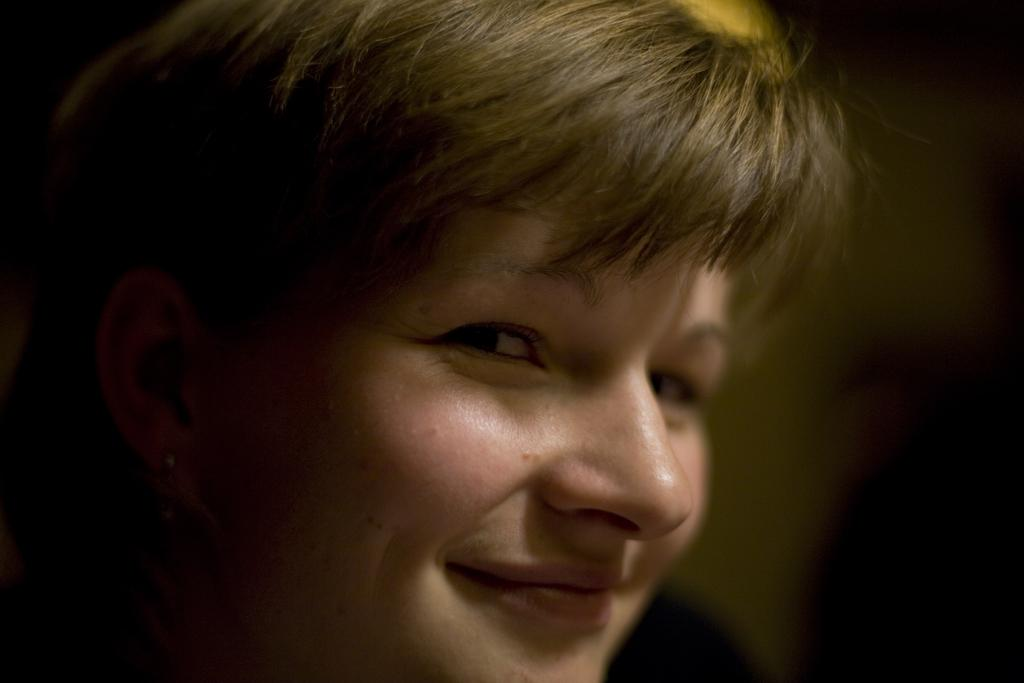What is the focus of the image? The image is zoomed in on a person's head in the foreground. What is the facial expression of the person in the image? The person is smiling. How would you describe the background of the image? The background of the image is blurry. Can you see a basketball being dribbled in the background of the image? There is no basketball or any dribbling activity present in the image. Is there a record player visible in the background of the image? There is no record player or any record-related objects present in the image. 